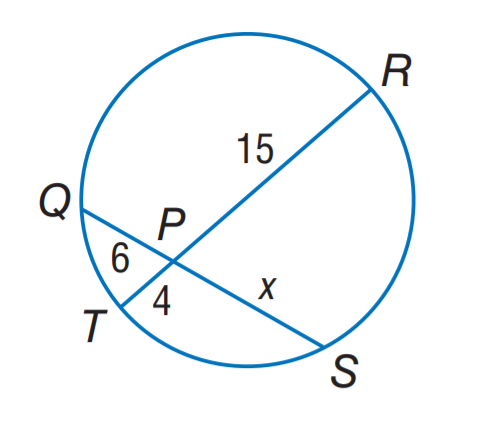Question: Find x.
Choices:
A. 4
B. 6
C. 10
D. 15
Answer with the letter. Answer: C 